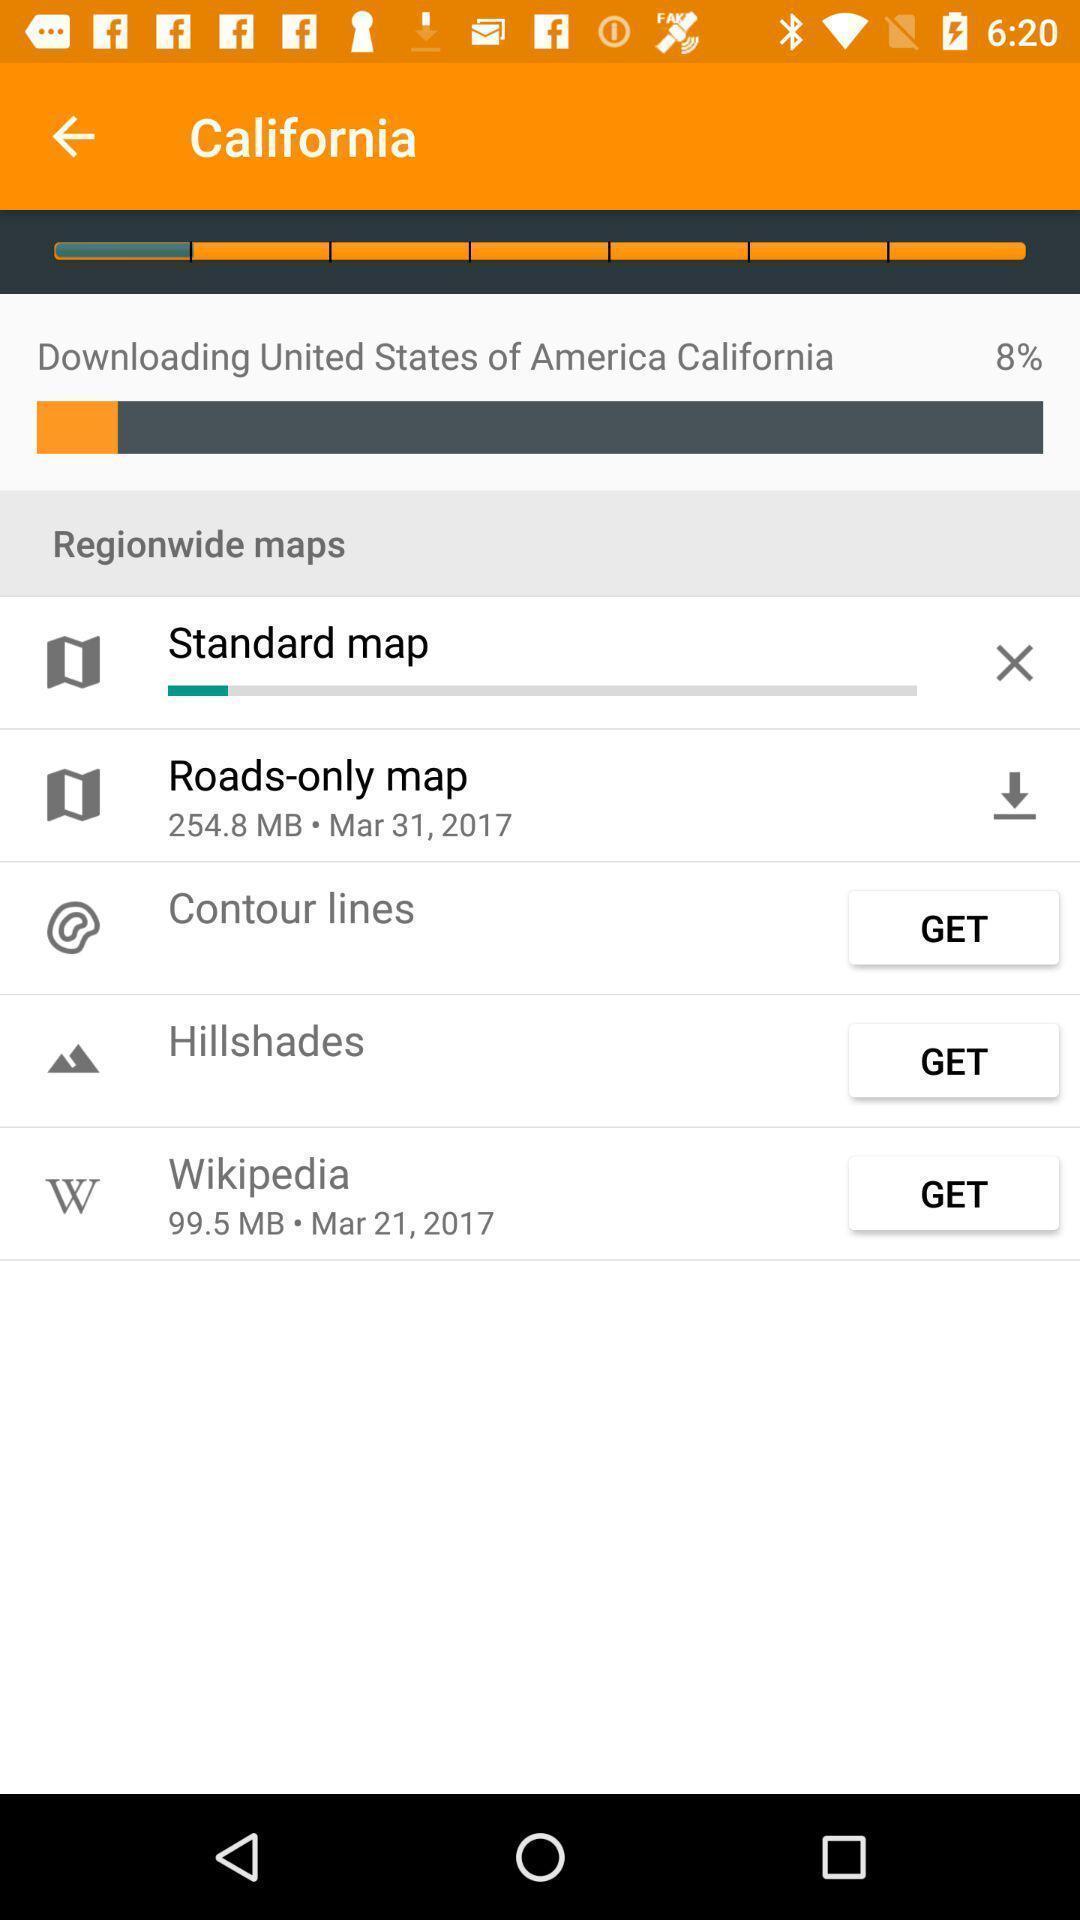Please provide a description for this image. Screen displaying multiple options with icons in a navigation application. 